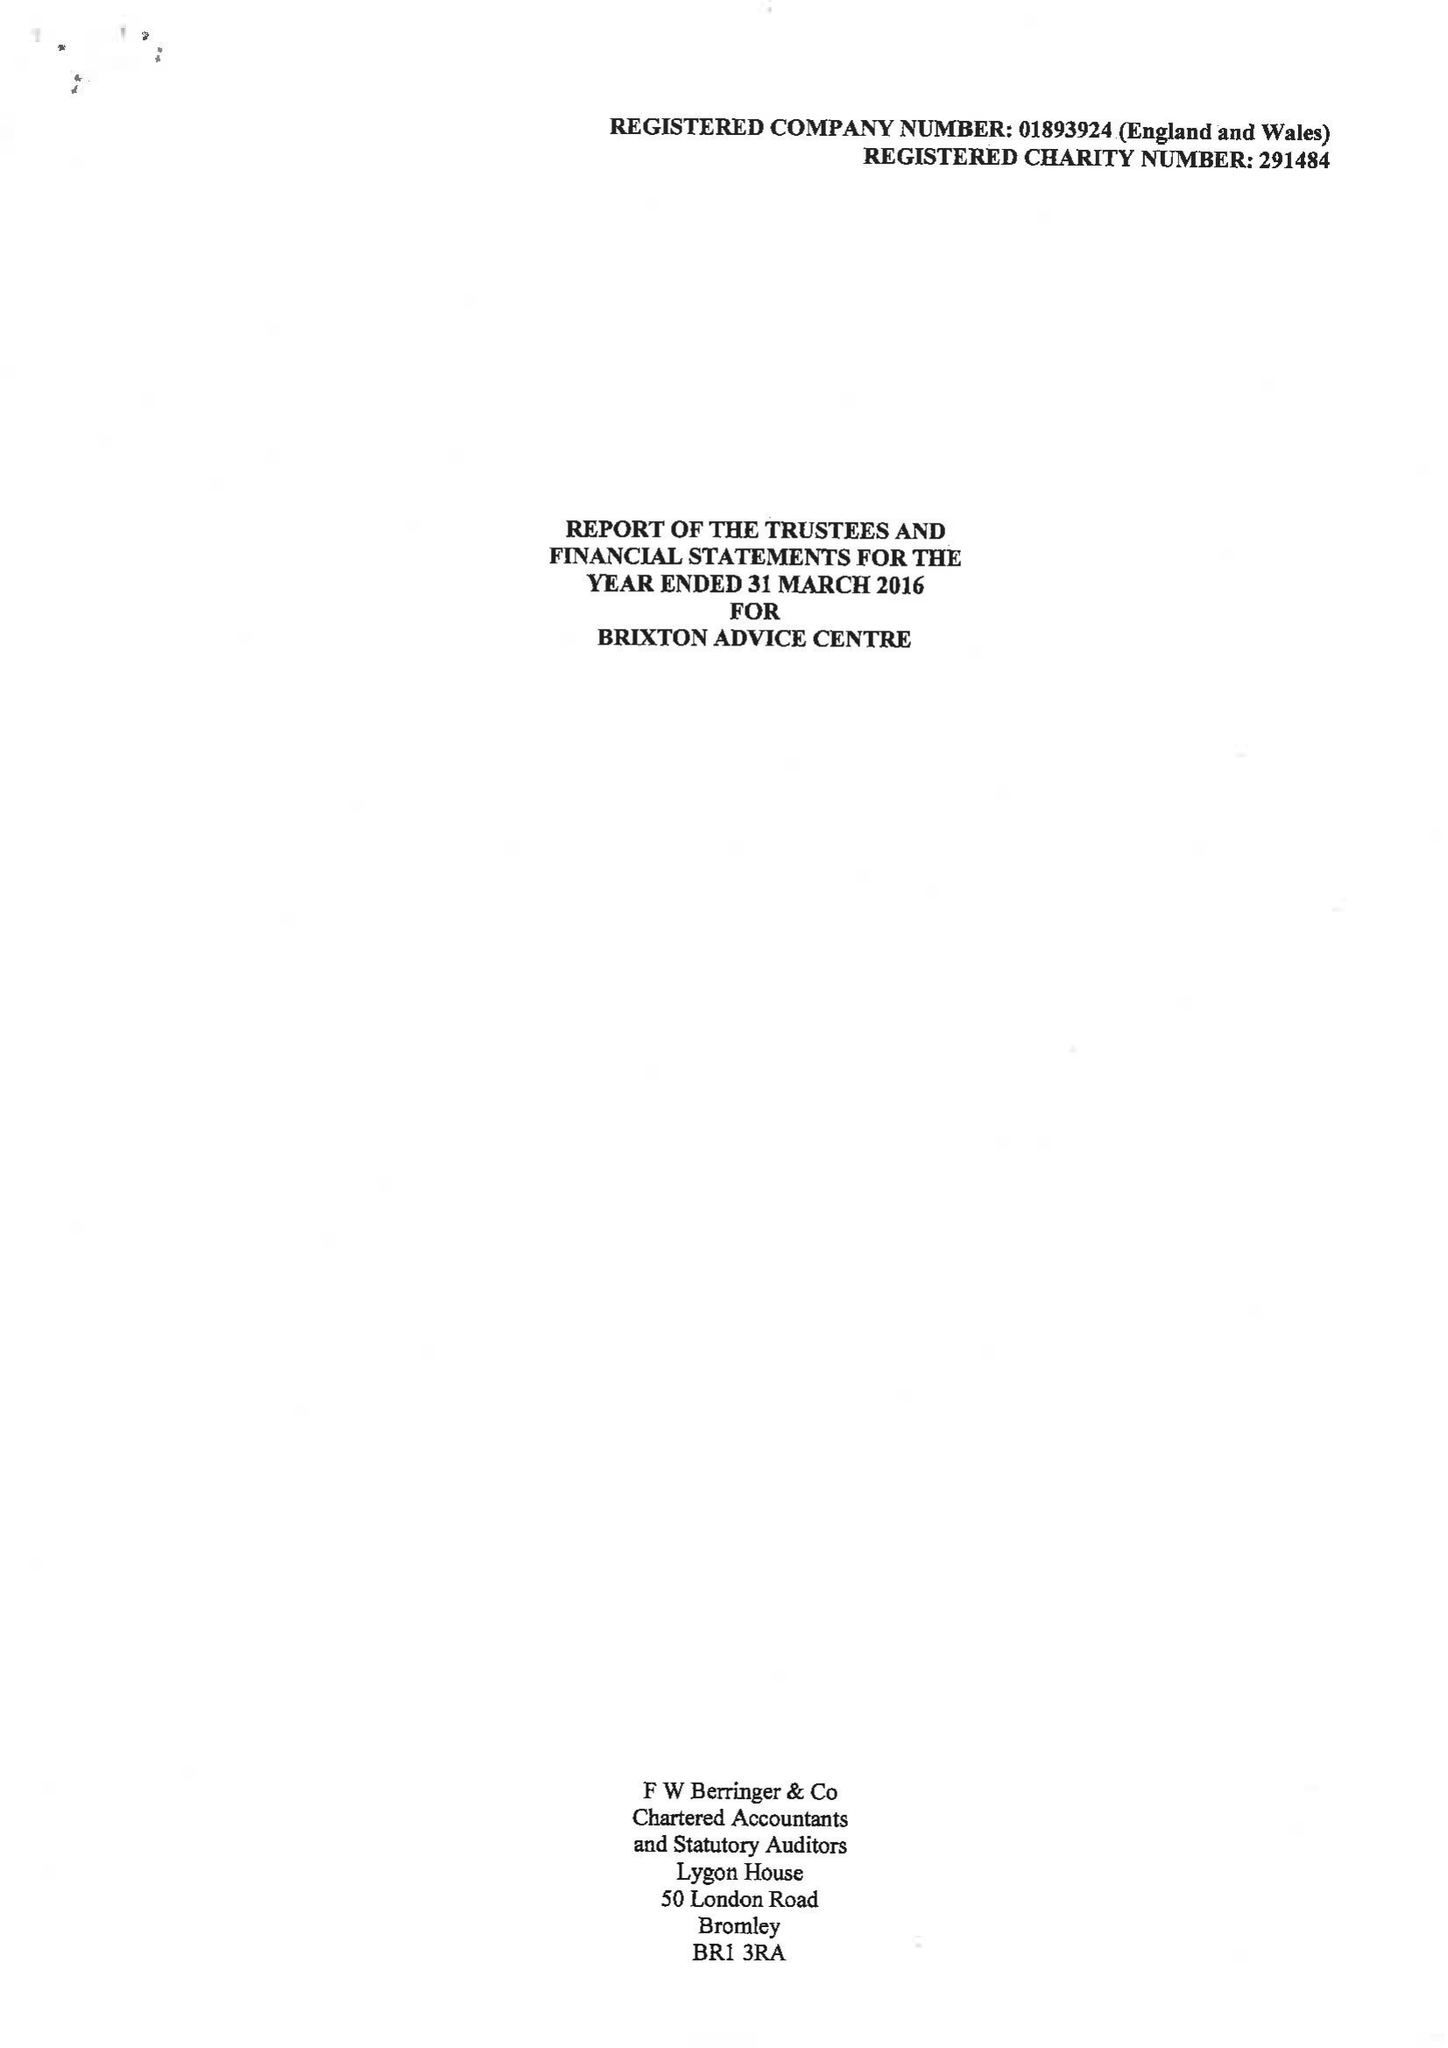What is the value for the address__street_line?
Answer the question using a single word or phrase. 165-167 RAILTON ROAD 